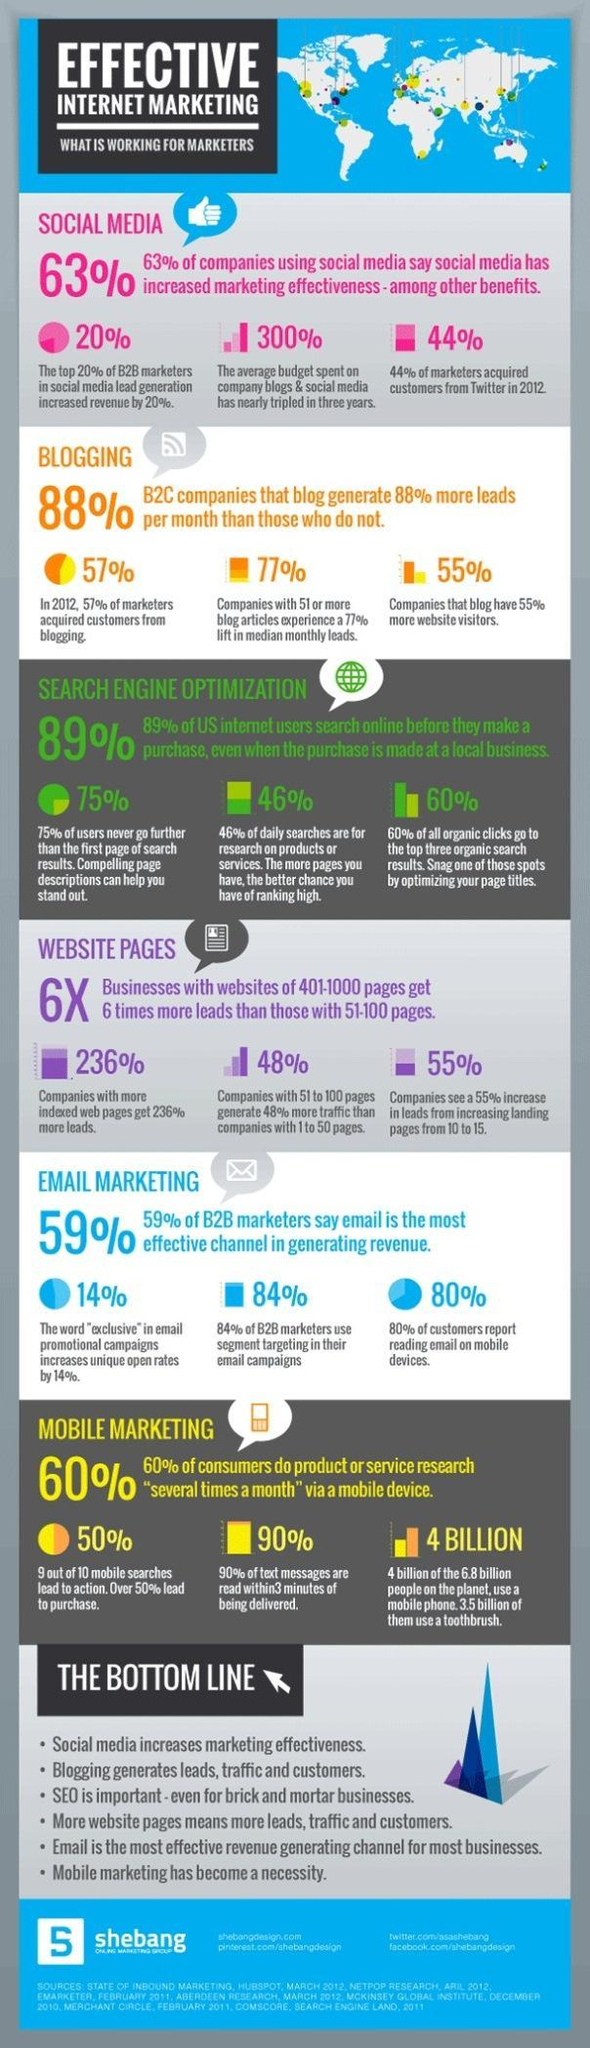What percentage of marketers feel that sending business mails can help in channelizing revenue, 59%, 14%, or 84%?
Answer the question with a short phrase. 59% What is the rise in income due to the lead generated through social media, 63%, 20%, or 44%? 20% What percentage of people mostly click the top most results displayed in the search engine, 75%, 46%, or 60%? 60% What is the percentage of new customers obtained through blogging, 57%, 55%, or  88%? 57% 